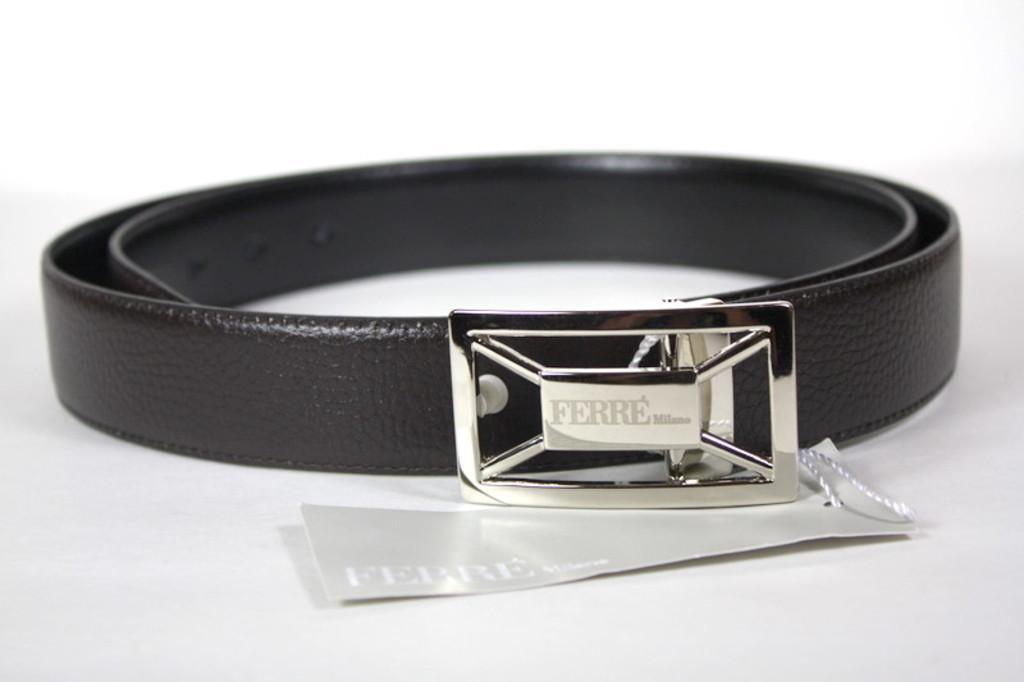What type of accessory is present in the image? There is a leather belt in the image. What is the color of the leather belt? The leather belt is black in color. Is there any additional information about the leather belt? Yes, there is a tag on the leather belt. What is the background color of the image? The remaining portion of the image is in white color. How many daughters are visible in the image? There are no daughters present in the image; it features a leather belt with a tag. What type of knee injury can be seen in the image? There is no knee injury present in the image; it features a leather belt with a tag. 